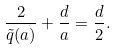<formula> <loc_0><loc_0><loc_500><loc_500>\frac { 2 } { \tilde { q } ( a ) } + \frac { d } { a } = \frac { d } { 2 } .</formula> 